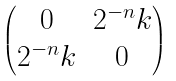<formula> <loc_0><loc_0><loc_500><loc_500>\begin{pmatrix} 0 & 2 ^ { - n } k \\ 2 ^ { - n } k & 0 \end{pmatrix}</formula> 